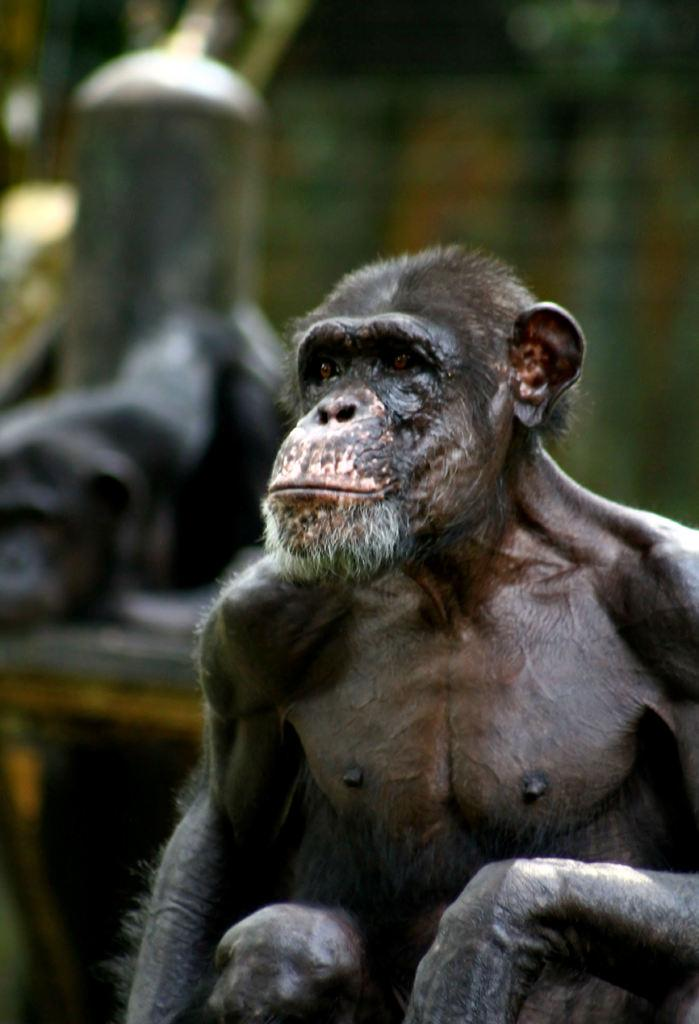What type of animal is in the picture? There is a monkey in the picture. Reasoning: Let's think step by identifying the main subject in the image, which is the monkey. We formulate a question that focuses on the type of animal present in the image, ensuring that the question can be answered definitively with the information given. We avoid yes/no questions and ensure that the language is simple and clear. Absurd Question/Answer: What type of beef is being mined from the mountain in the image? There is no beef, mine, or mountain present in the image; it features a monkey. What type of beef is being mined from the mountain in the image? There is no beef, mine, or mountain present in the image; it features a monkey. 